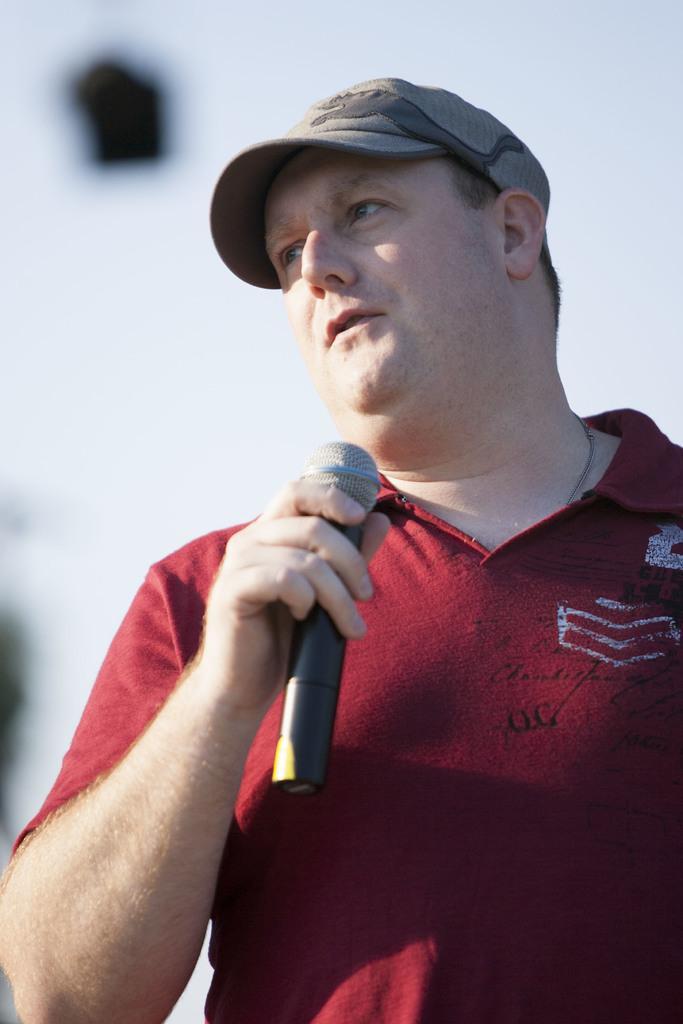Please provide a concise description of this image. In this picture I can observe a man wearing red color T shirt and holding a mic in his hand. He is wearing a hat on his head. The background is blurred. 